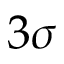Convert formula to latex. <formula><loc_0><loc_0><loc_500><loc_500>3 \sigma</formula> 